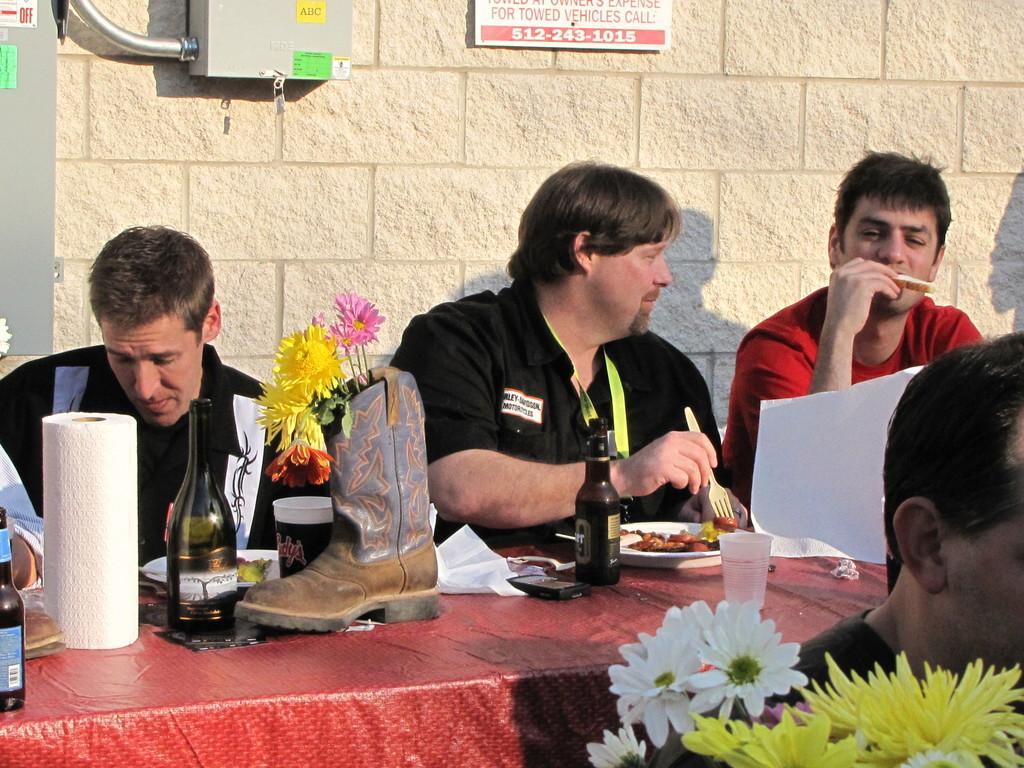How would you summarize this image in a sentence or two? In the middle of the picture we can see people, table, drink, flowers, food items, papers and other objects. In the foreground there are flowers and a person. In the background we can see wall, board, box, pipe and a pole. 